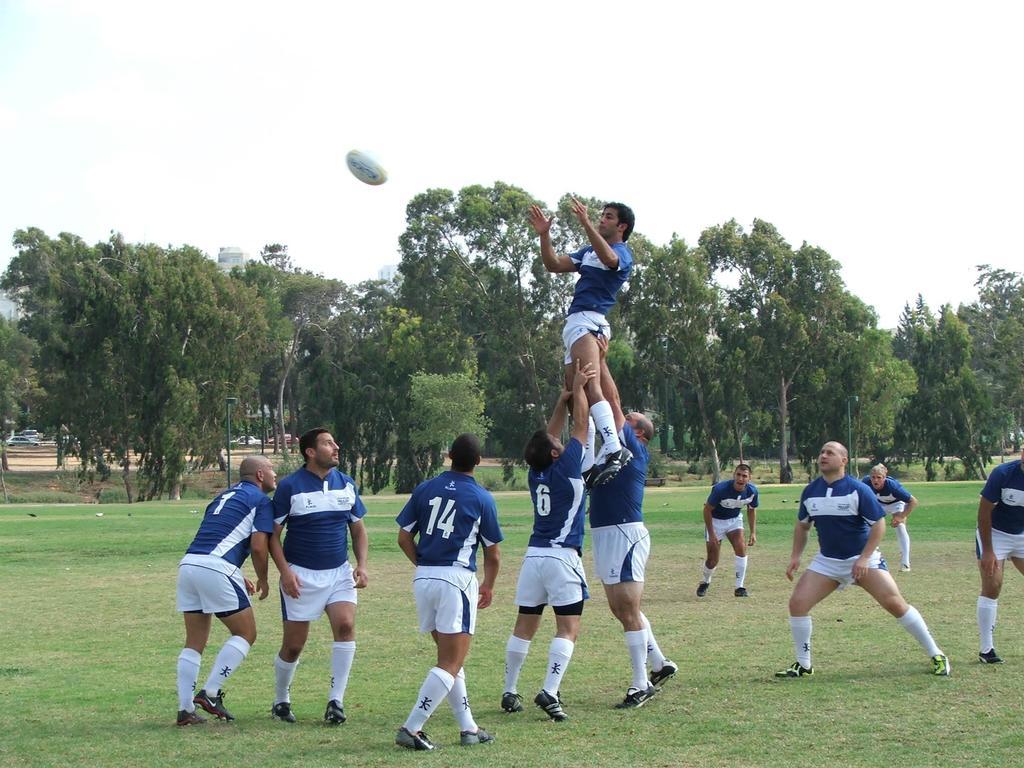What jersey number is the third player from the left?
Provide a short and direct response. 14. 